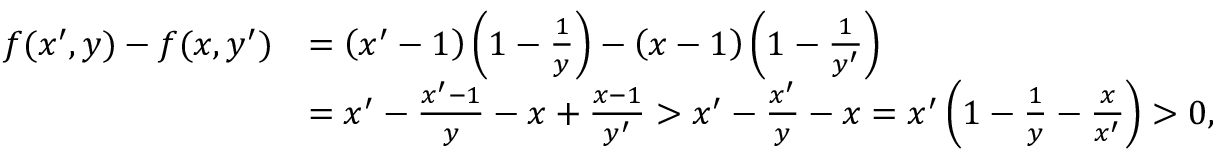Convert formula to latex. <formula><loc_0><loc_0><loc_500><loc_500>\begin{array} { r l } { f ( x ^ { \prime } , y ) - f ( x , y ^ { \prime } ) } & { = \left ( x ^ { \prime } - 1 \right ) \left ( 1 - \frac { 1 } { y } \right ) - \left ( x - 1 \right ) \left ( 1 - \frac { 1 } { y ^ { \prime } } \right ) } \\ & { = x ^ { \prime } - \frac { x ^ { \prime } - 1 } { y } - x + \frac { x - 1 } { y ^ { \prime } } > x ^ { \prime } - \frac { x ^ { \prime } } { y } - x = x ^ { \prime } \left ( 1 - \frac { 1 } { y } - \frac { x } { x ^ { \prime } } \right ) > 0 , } \end{array}</formula> 